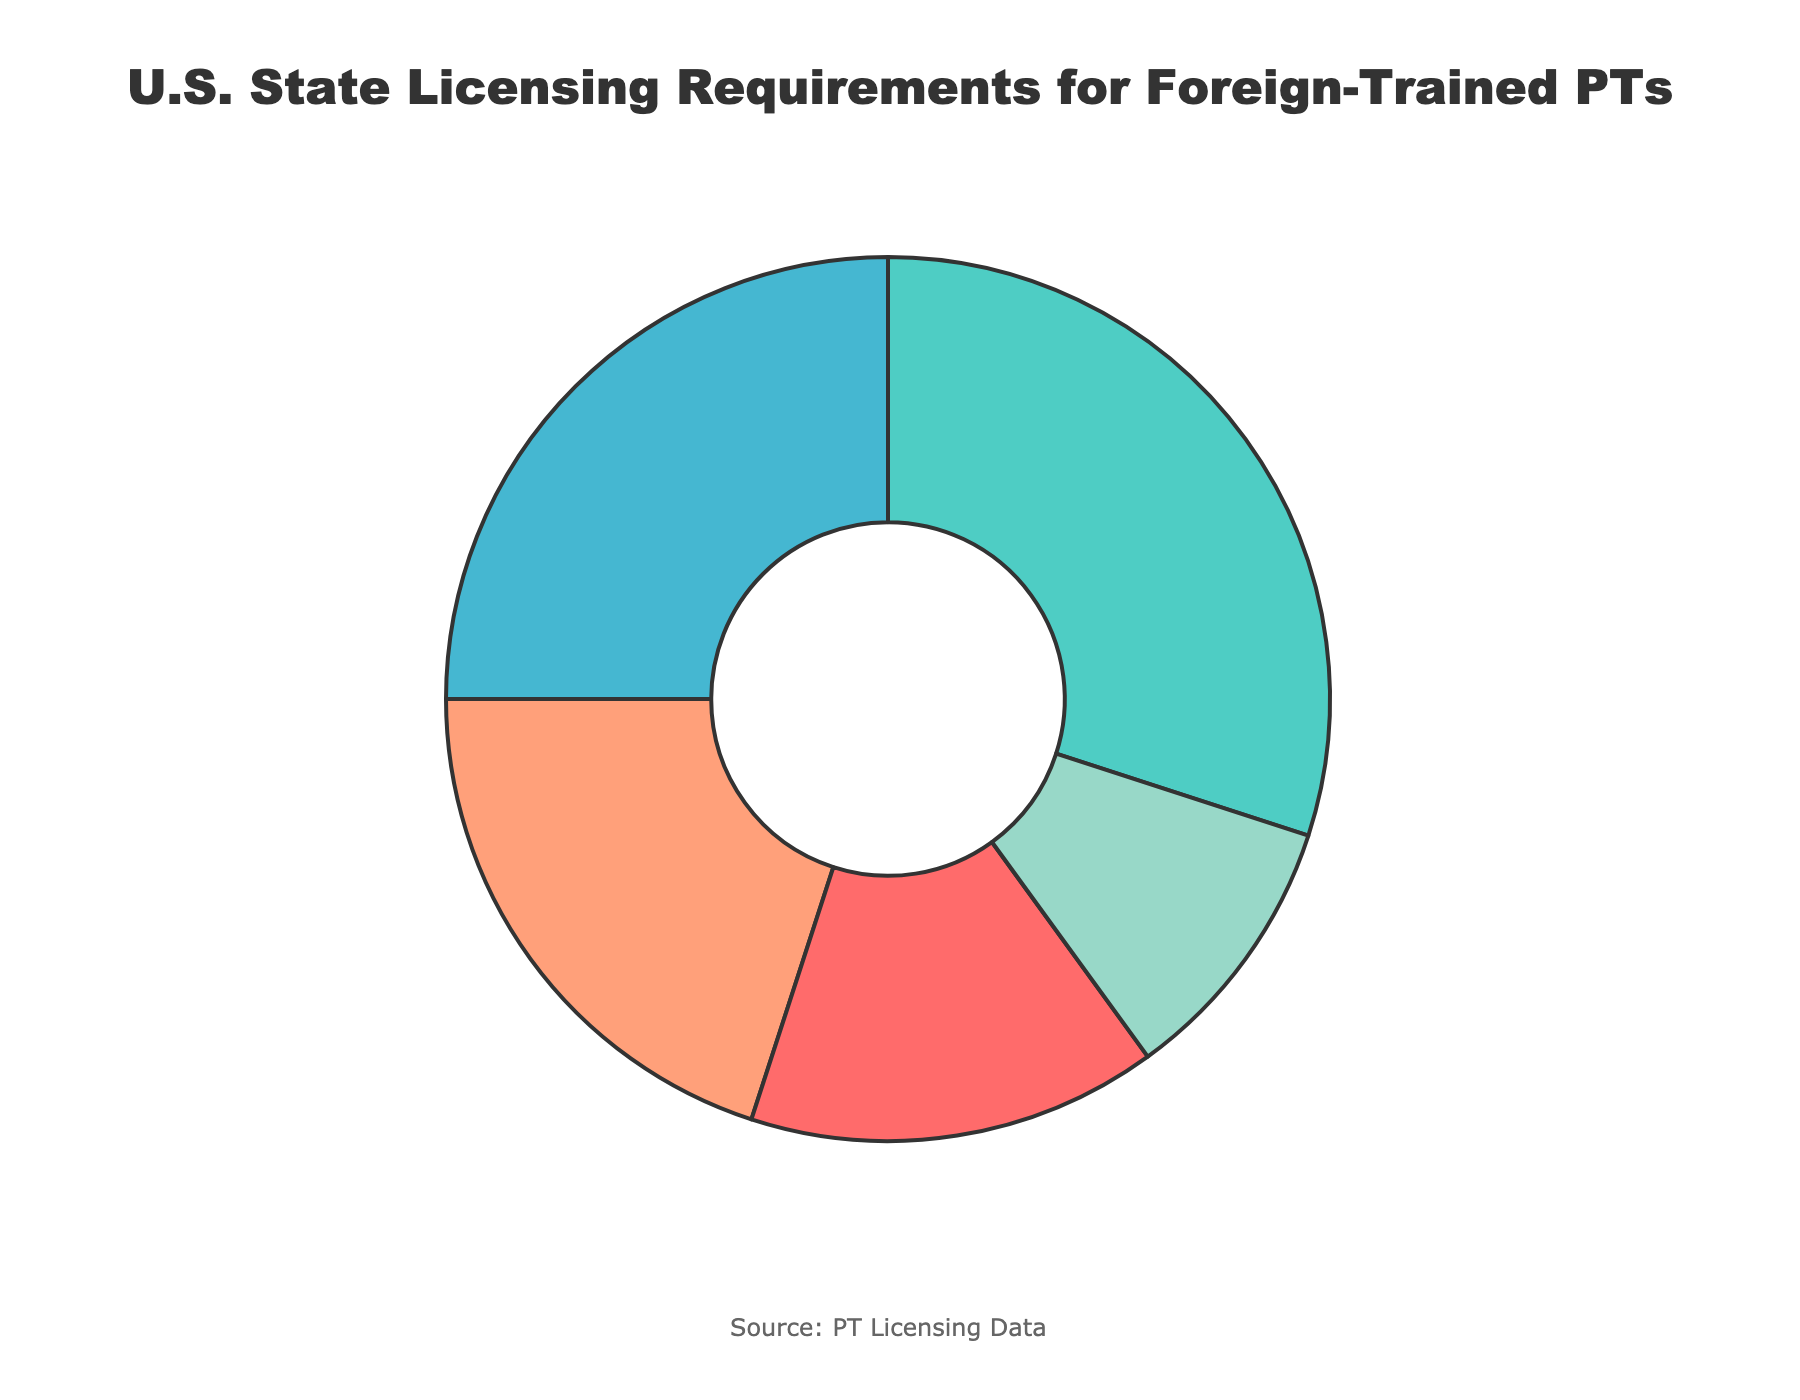What percentage of states require additional clinical hours? The section labeled "Additional Clinical Hours Required" shows 30%, as indicated in the pie chart.
Answer: 30% Which requirement is least common among U.S. states? The smallest segment in the pie chart is "Supervised Practice Period Necessary," which represents 10%.
Answer: Supervised Practice Period Necessary What is the total percentage for states that either require a state-specific exam or a bridge program completion? Add the percentages for "State-Specific Exam Required" (20%) and "Bridge Program Completion Mandatory" (25%). Therefore, 20% + 25% = 45%.
Answer: 45% How many more states require additional clinical hours than those requiring supervised practice periods? Subtract the percentage of "Supervised Practice Period Necessary" (10%) from "Additional Clinical Hours Required" (30%) to find the difference. Hence, 30% - 10% = 20%.
Answer: 20% Which requirement is more common: bridge program completion or a state-specific exam? Compare the two segments: "Bridge Program Completion Mandatory" shows 25%, while "State-Specific Exam Required" shows 20%.
Answer: Bridge Program Completion Mandatory What proportion of states allow a full license without additional training compared to those that require supervised practice periods? Compare the percentages of "Full License without Additional Training" (15%) and "Supervised Practice Period Necessary" (10%). 15% is 1.5 times 10%.
Answer: 1.5 times What is the combined percentage of states that have stricter requirements, meaning either bridge program completion or additional clinical hours required? Add the percentages of "Bridge Program Completion Mandatory" (25%) and "Additional Clinical Hours Required" (30%). Thus, 25% + 30% = 55%.
Answer: 55% Which requirement category is represented by the second-largest segment? The second-largest section of the pie chart represents "Bridge Program Completion Mandatory" at 25%.
Answer: Bridge Program Completion Mandatory How does the percentage of states with a state-specific exam requirement compare to those requiring additional clinical hours? Compare the two segments, where "State-Specific Exam Required" is 20% and "Additional Clinical Hours Required" is 30%. 20% is lesser than 30%.
Answer: Less 